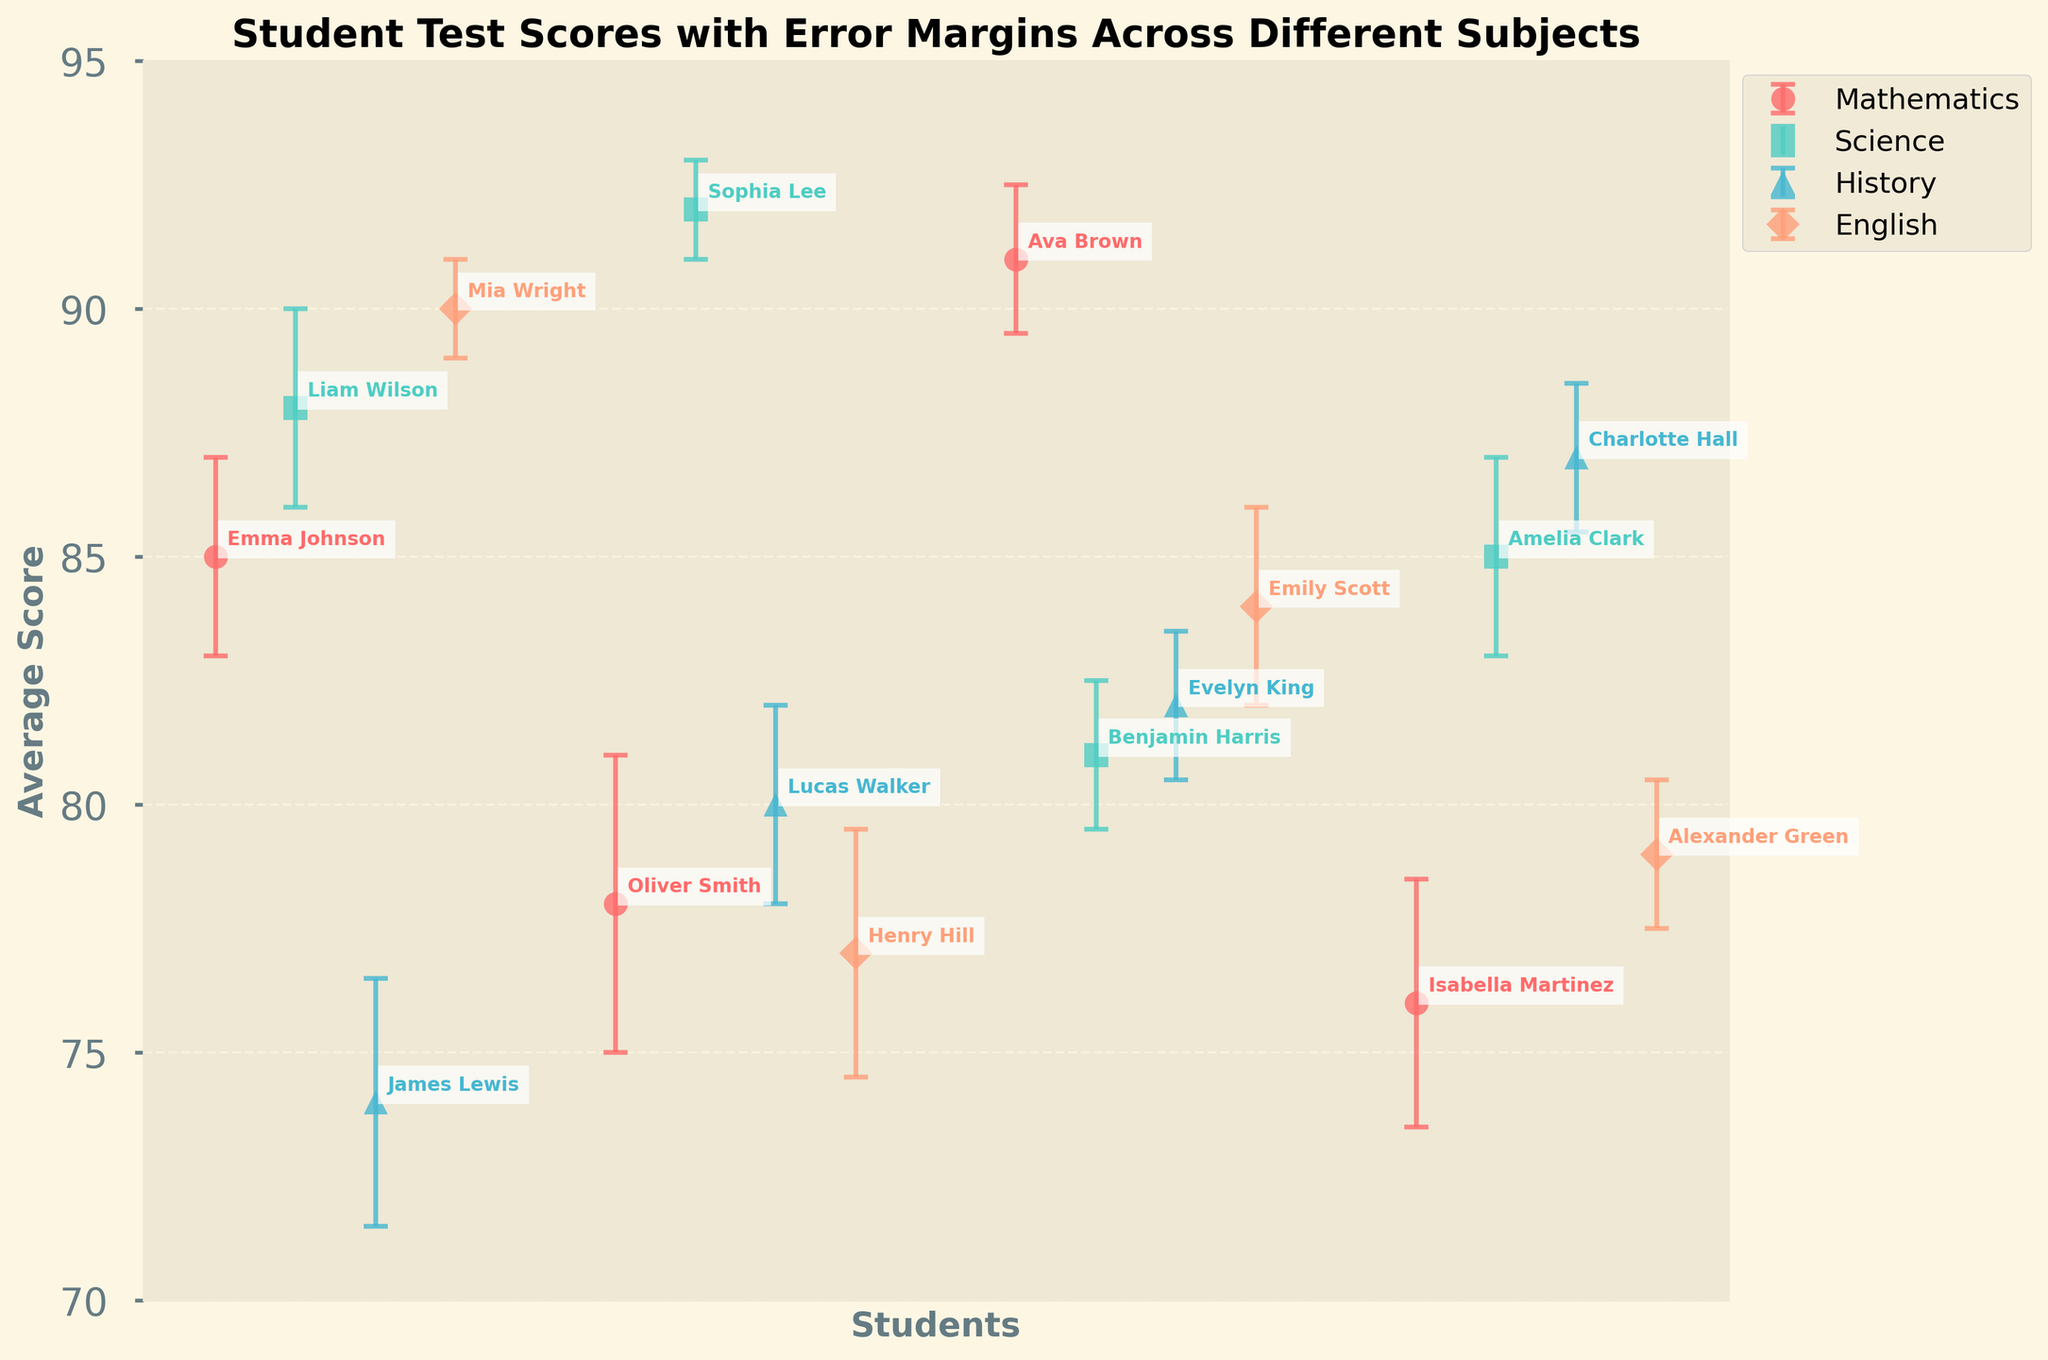What is the title of the plot? Look at the top of the figure where the title is typically placed. It reads "Student Test Scores with Error Margins Across Different Subjects".
Answer: Student Test Scores with Error Margins Across Different Subjects Which subject has the highest average score? To find the highest average score, scan through the scores in each subject and note the maximum value. Sophia Lee in Science has the highest average score of 92.
Answer: Science How many students are represented in the plot? Count the number of students listed under each subject. There are 4 students in each of the 4 subjects, which totals 16 students.
Answer: 16 What's the average score for students in Mathematics? Add up the scores for all students in Mathematics: 85 (Emma), 78 (Oliver), 91 (Ava), and 76 (Isabella). Then divide by 4. The calculation is (85 + 78 + 91 + 76) / 4 = 330 / 4 = 82.5.
Answer: 82.5 Which student has the smallest error margin in their scores? Compare the error margins (yerr) for each student and find the smallest one. Sophia Lee in Science has the smallest error margin of 1.
Answer: Sophia Lee Which subject has the overall lowest average scores? Observe the average scores for each student in each subject. History has the lowest scores, with James Lewis at 74.
Answer: History What is the difference in average scores between the highest-scoring and lowest-scoring students in English? Identify the highest and lowest scores in English, which are 90 (Mia Wright) and 77 (Henry Hill), respectively. Calculate the difference: 90 - 77 = 13.
Answer: 13 Who scored the highest in Mathematics, and what is their score? Among the Mathematics students, Ava Brown has the highest score of 91.
Answer: Ava Brown, 91 Compare the average scores of Emma Johnson in Mathematics and Sophia Lee in Science. Which score is higher, and by how much? Emma Johnson scored 85, while Sophia Lee scored 92. The difference is 92 - 85 = 7, with Sophia Lee scoring higher.
Answer: Sophia Lee by 7 Which subject has the lowest variation in scores based on error margins? To find the subject with the lowest variation, we look for the smallest error margins. English has relatively consistent error margins: 1, 2.5, 2, and 1.5.
Answer: English 